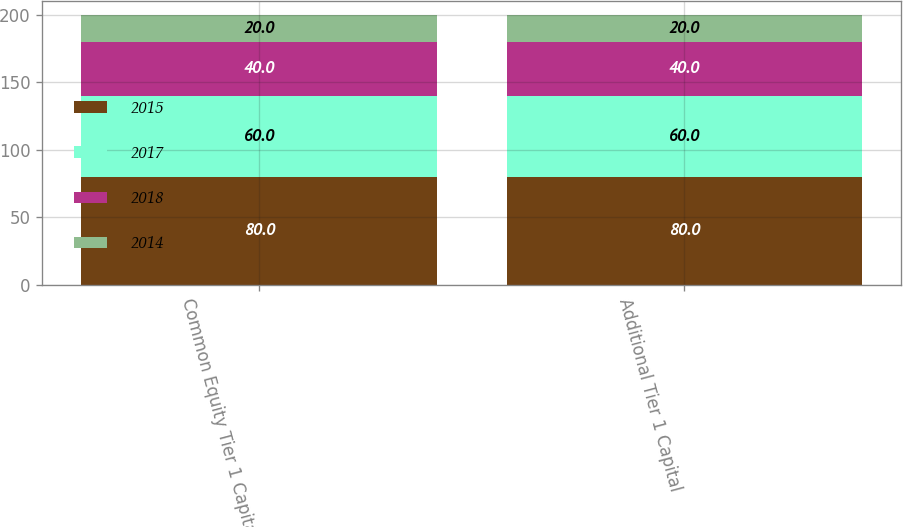Convert chart. <chart><loc_0><loc_0><loc_500><loc_500><stacked_bar_chart><ecel><fcel>Common Equity Tier 1 Capital<fcel>Additional Tier 1 Capital<nl><fcel>2015<fcel>80<fcel>80<nl><fcel>2017<fcel>60<fcel>60<nl><fcel>2018<fcel>40<fcel>40<nl><fcel>2014<fcel>20<fcel>20<nl></chart> 